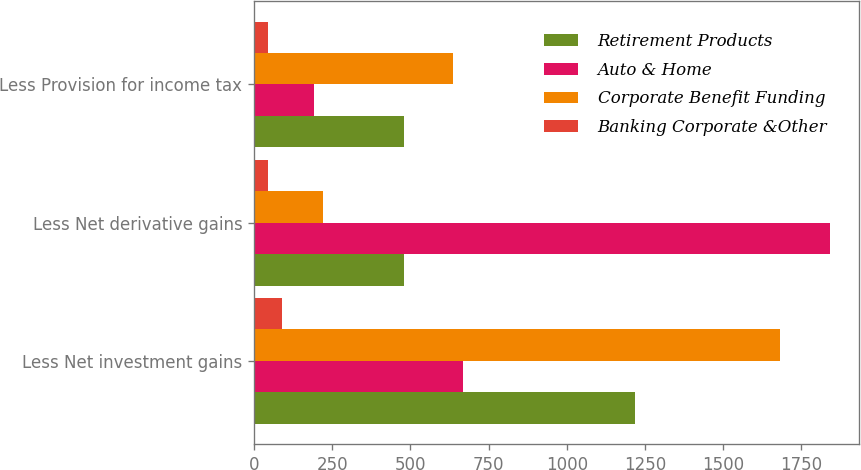<chart> <loc_0><loc_0><loc_500><loc_500><stacked_bar_chart><ecel><fcel>Less Net investment gains<fcel>Less Net derivative gains<fcel>Less Provision for income tax<nl><fcel>Retirement Products<fcel>1219<fcel>480<fcel>480<nl><fcel>Auto & Home<fcel>669<fcel>1842<fcel>192<nl><fcel>Corporate Benefit Funding<fcel>1682<fcel>219<fcel>637<nl><fcel>Banking Corporate &Other<fcel>89<fcel>45<fcel>46<nl></chart> 